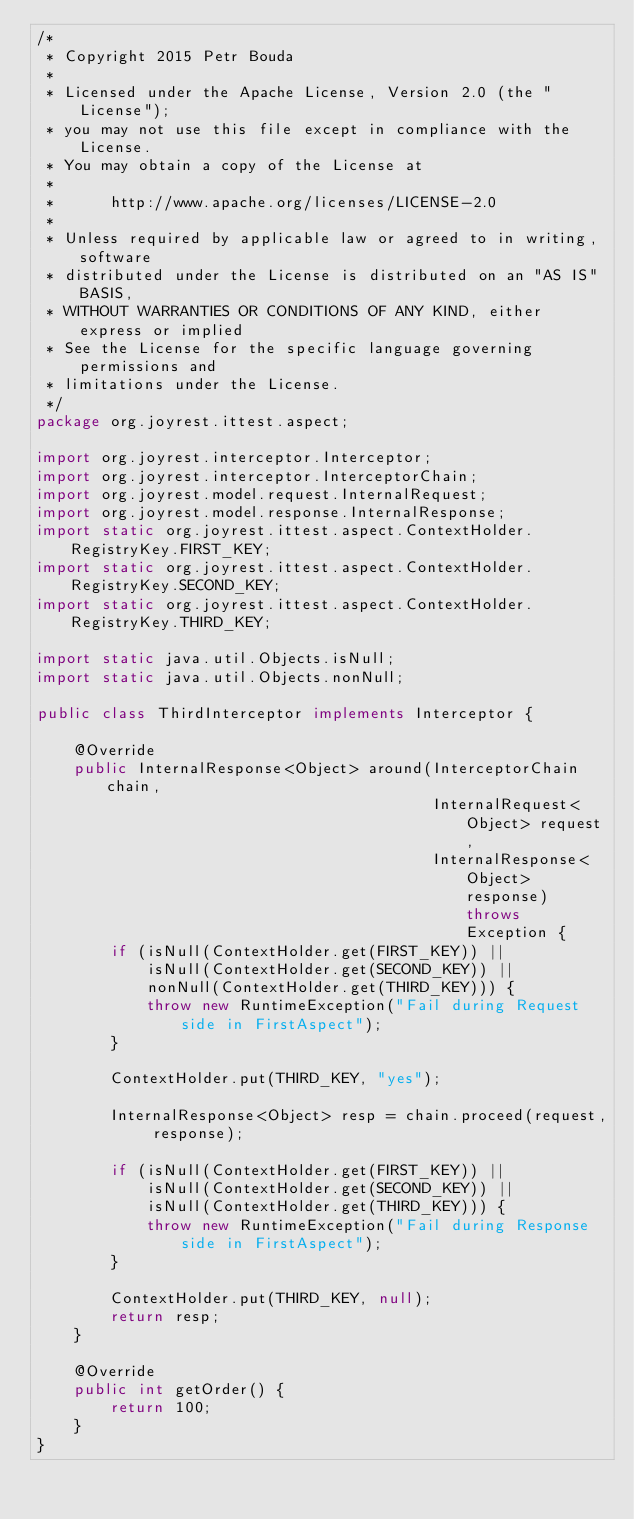<code> <loc_0><loc_0><loc_500><loc_500><_Java_>/*
 * Copyright 2015 Petr Bouda
 *
 * Licensed under the Apache License, Version 2.0 (the "License");
 * you may not use this file except in compliance with the License.
 * You may obtain a copy of the License at
 *
 *      http://www.apache.org/licenses/LICENSE-2.0
 *
 * Unless required by applicable law or agreed to in writing, software
 * distributed under the License is distributed on an "AS IS" BASIS,
 * WITHOUT WARRANTIES OR CONDITIONS OF ANY KIND, either express or implied
 * See the License for the specific language governing permissions and
 * limitations under the License.
 */
package org.joyrest.ittest.aspect;

import org.joyrest.interceptor.Interceptor;
import org.joyrest.interceptor.InterceptorChain;
import org.joyrest.model.request.InternalRequest;
import org.joyrest.model.response.InternalResponse;
import static org.joyrest.ittest.aspect.ContextHolder.RegistryKey.FIRST_KEY;
import static org.joyrest.ittest.aspect.ContextHolder.RegistryKey.SECOND_KEY;
import static org.joyrest.ittest.aspect.ContextHolder.RegistryKey.THIRD_KEY;

import static java.util.Objects.isNull;
import static java.util.Objects.nonNull;

public class ThirdInterceptor implements Interceptor {

    @Override
    public InternalResponse<Object> around(InterceptorChain chain,
                                           InternalRequest<Object> request,
                                           InternalResponse<Object> response) throws Exception {
        if (isNull(ContextHolder.get(FIRST_KEY)) ||
            isNull(ContextHolder.get(SECOND_KEY)) ||
            nonNull(ContextHolder.get(THIRD_KEY))) {
            throw new RuntimeException("Fail during Request side in FirstAspect");
        }

        ContextHolder.put(THIRD_KEY, "yes");

        InternalResponse<Object> resp = chain.proceed(request, response);

        if (isNull(ContextHolder.get(FIRST_KEY)) ||
            isNull(ContextHolder.get(SECOND_KEY)) ||
            isNull(ContextHolder.get(THIRD_KEY))) {
            throw new RuntimeException("Fail during Response side in FirstAspect");
        }

        ContextHolder.put(THIRD_KEY, null);
        return resp;
    }

    @Override
    public int getOrder() {
        return 100;
    }
}
</code> 